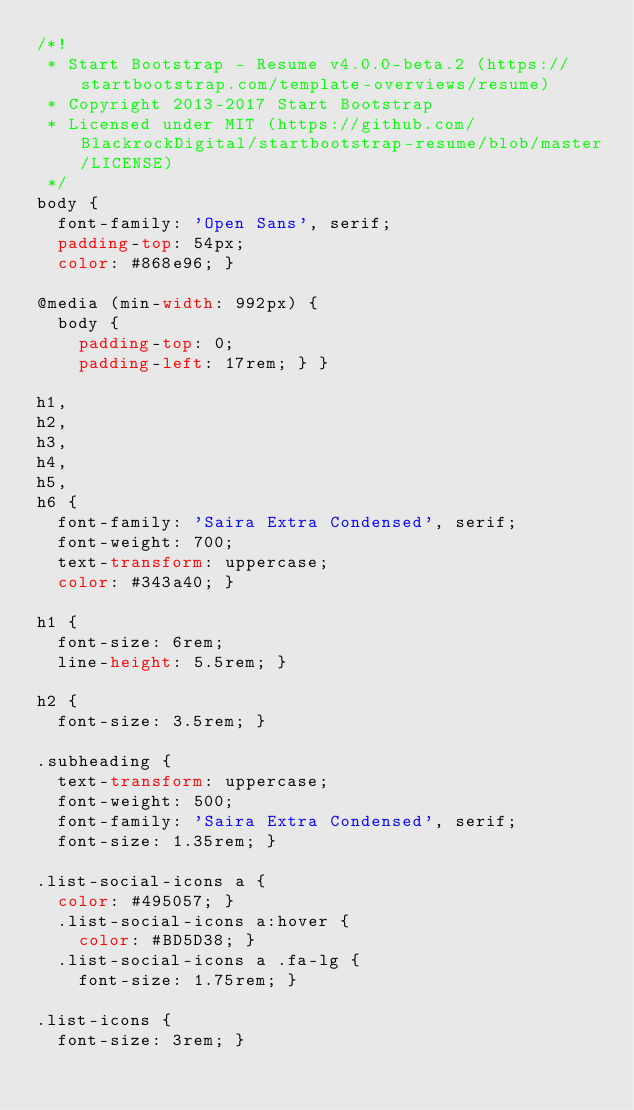<code> <loc_0><loc_0><loc_500><loc_500><_CSS_>/*!
 * Start Bootstrap - Resume v4.0.0-beta.2 (https://startbootstrap.com/template-overviews/resume)
 * Copyright 2013-2017 Start Bootstrap
 * Licensed under MIT (https://github.com/BlackrockDigital/startbootstrap-resume/blob/master/LICENSE)
 */
body {
  font-family: 'Open Sans', serif;
  padding-top: 54px;
  color: #868e96; }

@media (min-width: 992px) {
  body {
    padding-top: 0;
    padding-left: 17rem; } }

h1,
h2,
h3,
h4,
h5,
h6 {
  font-family: 'Saira Extra Condensed', serif;
  font-weight: 700;
  text-transform: uppercase;
  color: #343a40; }

h1 {
  font-size: 6rem;
  line-height: 5.5rem; }

h2 {
  font-size: 3.5rem; }

.subheading {
  text-transform: uppercase;
  font-weight: 500;
  font-family: 'Saira Extra Condensed', serif;
  font-size: 1.35rem; }

.list-social-icons a {
  color: #495057; }
  .list-social-icons a:hover {
    color: #BD5D38; }
  .list-social-icons a .fa-lg {
    font-size: 1.75rem; }

.list-icons {
  font-size: 3rem; }</code> 